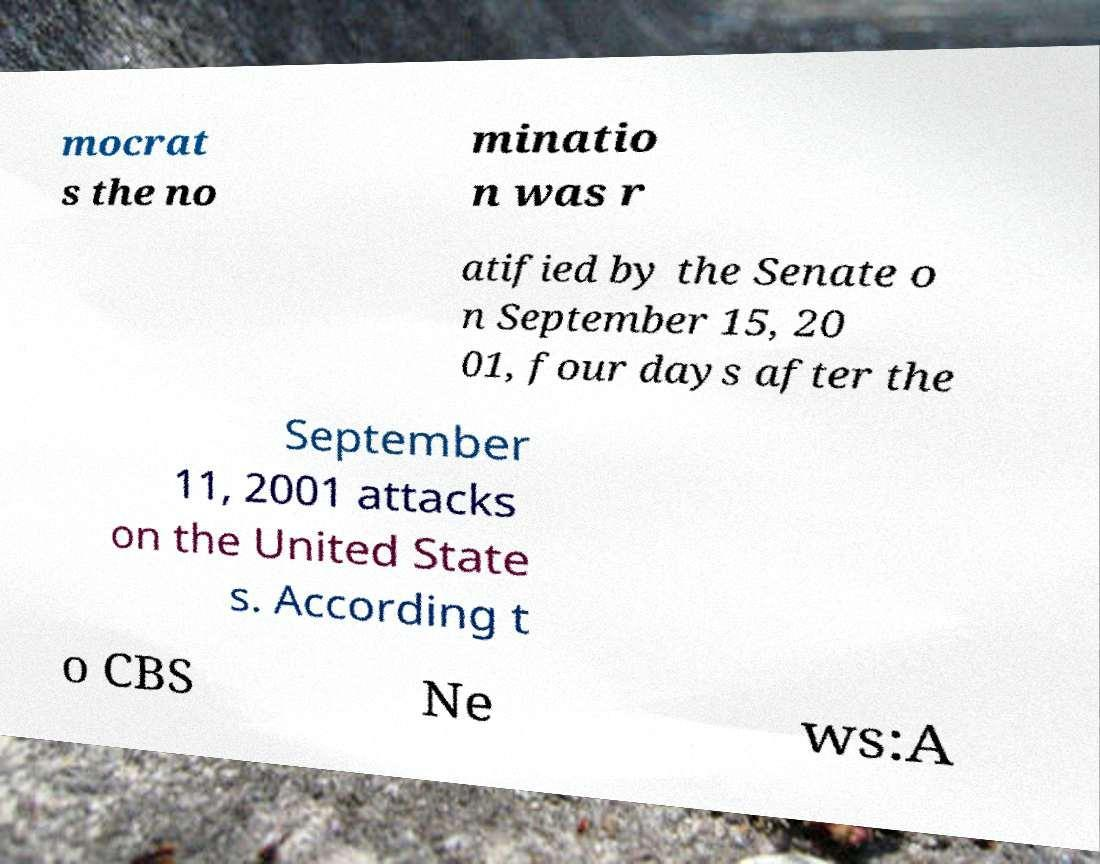Can you read and provide the text displayed in the image?This photo seems to have some interesting text. Can you extract and type it out for me? mocrat s the no minatio n was r atified by the Senate o n September 15, 20 01, four days after the September 11, 2001 attacks on the United State s. According t o CBS Ne ws:A 